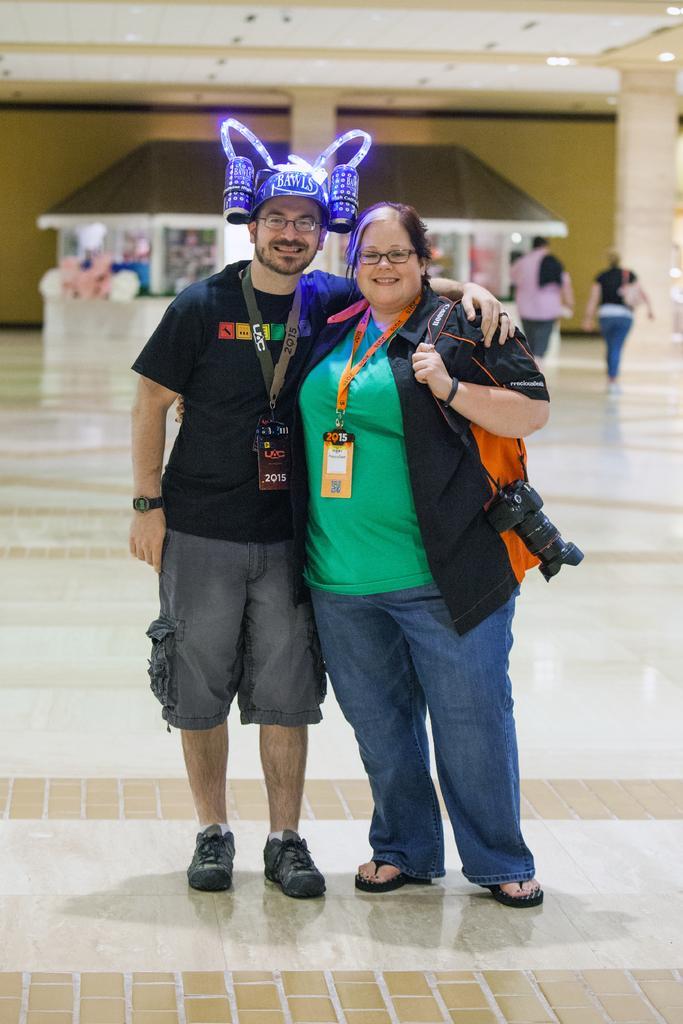Can you describe this image briefly? The picture is taken in a building. In the foreground of the picture there is a man and woman standing. The woman is is holding a camera. The background is blurred. In the background there are people and shops. At the top it is ceiling. 